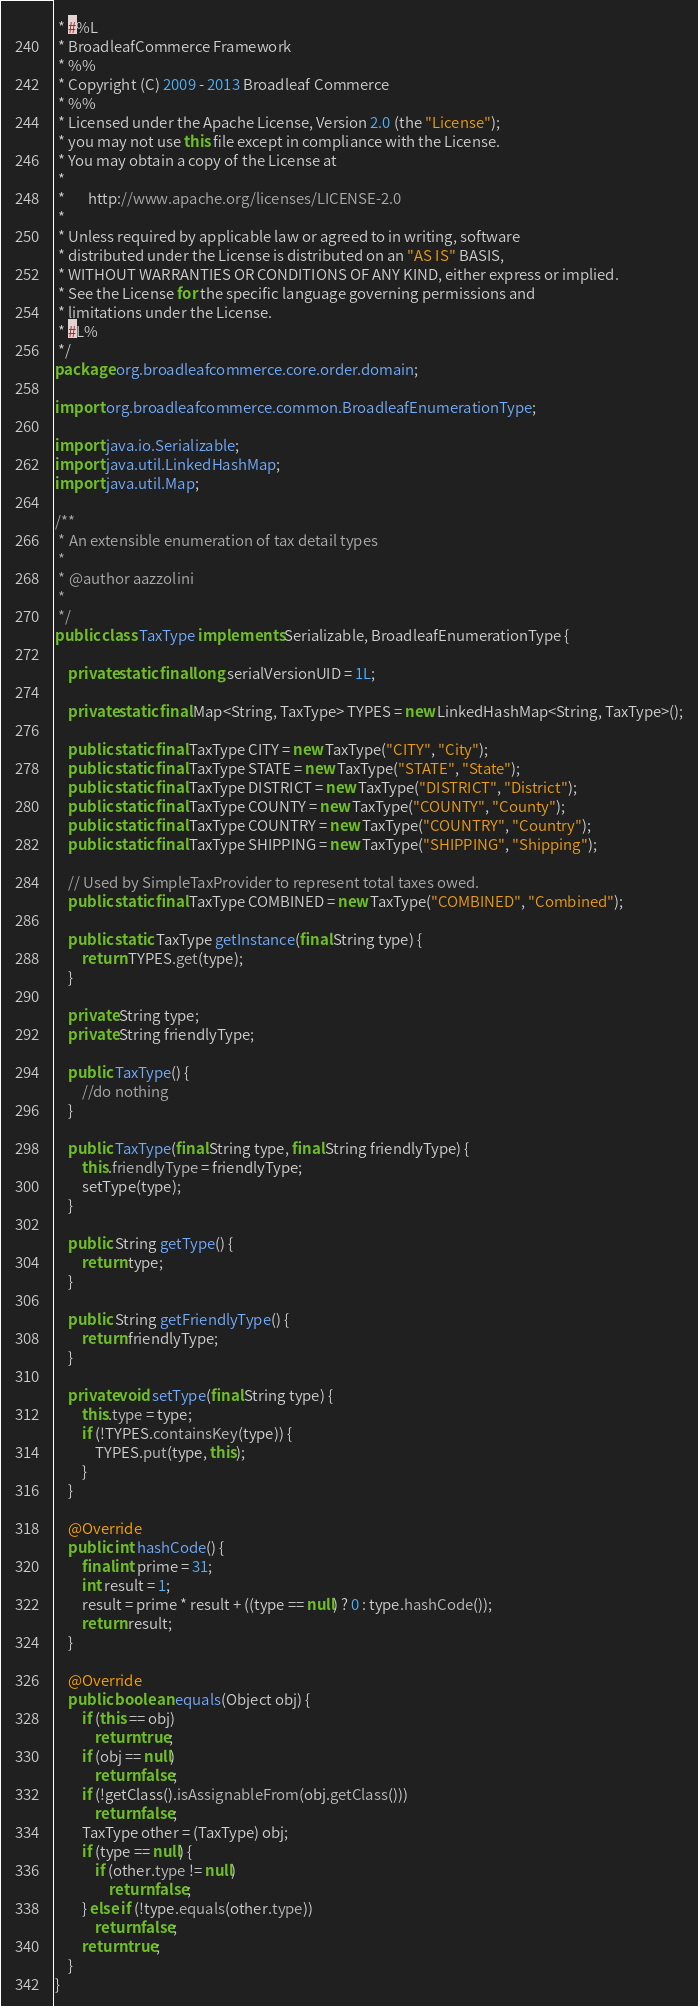<code> <loc_0><loc_0><loc_500><loc_500><_Java_> * #%L
 * BroadleafCommerce Framework
 * %%
 * Copyright (C) 2009 - 2013 Broadleaf Commerce
 * %%
 * Licensed under the Apache License, Version 2.0 (the "License");
 * you may not use this file except in compliance with the License.
 * You may obtain a copy of the License at
 * 
 *       http://www.apache.org/licenses/LICENSE-2.0
 * 
 * Unless required by applicable law or agreed to in writing, software
 * distributed under the License is distributed on an "AS IS" BASIS,
 * WITHOUT WARRANTIES OR CONDITIONS OF ANY KIND, either express or implied.
 * See the License for the specific language governing permissions and
 * limitations under the License.
 * #L%
 */
package org.broadleafcommerce.core.order.domain;

import org.broadleafcommerce.common.BroadleafEnumerationType;

import java.io.Serializable;
import java.util.LinkedHashMap;
import java.util.Map;

/**
 * An extensible enumeration of tax detail types
 * 
 * @author aazzolini
 *
 */
public class TaxType implements Serializable, BroadleafEnumerationType {

    private static final long serialVersionUID = 1L;

    private static final Map<String, TaxType> TYPES = new LinkedHashMap<String, TaxType>();

    public static final TaxType CITY = new TaxType("CITY", "City");
    public static final TaxType STATE = new TaxType("STATE", "State");
    public static final TaxType DISTRICT = new TaxType("DISTRICT", "District");
    public static final TaxType COUNTY = new TaxType("COUNTY", "County");
    public static final TaxType COUNTRY = new TaxType("COUNTRY", "Country");
    public static final TaxType SHIPPING = new TaxType("SHIPPING", "Shipping");

    // Used by SimpleTaxProvider to represent total taxes owed.
    public static final TaxType COMBINED = new TaxType("COMBINED", "Combined");

    public static TaxType getInstance(final String type) {
        return TYPES.get(type);
    }

    private String type;
    private String friendlyType;

    public TaxType() {
        //do nothing
    }

    public TaxType(final String type, final String friendlyType) {
        this.friendlyType = friendlyType;
        setType(type);
    }

    public String getType() {
        return type;
    }

    public String getFriendlyType() {
        return friendlyType;
    }

    private void setType(final String type) {
        this.type = type;
        if (!TYPES.containsKey(type)) {
            TYPES.put(type, this);
        }
    }

    @Override
    public int hashCode() {
        final int prime = 31;
        int result = 1;
        result = prime * result + ((type == null) ? 0 : type.hashCode());
        return result;
    }

    @Override
    public boolean equals(Object obj) {
        if (this == obj)
            return true;
        if (obj == null)
            return false;
        if (!getClass().isAssignableFrom(obj.getClass()))
            return false;
        TaxType other = (TaxType) obj;
        if (type == null) {
            if (other.type != null)
                return false;
        } else if (!type.equals(other.type))
            return false;
        return true;
    }
}
</code> 